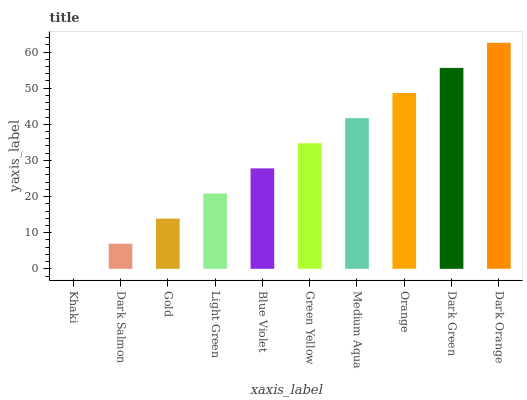Is Khaki the minimum?
Answer yes or no. Yes. Is Dark Orange the maximum?
Answer yes or no. Yes. Is Dark Salmon the minimum?
Answer yes or no. No. Is Dark Salmon the maximum?
Answer yes or no. No. Is Dark Salmon greater than Khaki?
Answer yes or no. Yes. Is Khaki less than Dark Salmon?
Answer yes or no. Yes. Is Khaki greater than Dark Salmon?
Answer yes or no. No. Is Dark Salmon less than Khaki?
Answer yes or no. No. Is Green Yellow the high median?
Answer yes or no. Yes. Is Blue Violet the low median?
Answer yes or no. Yes. Is Khaki the high median?
Answer yes or no. No. Is Dark Orange the low median?
Answer yes or no. No. 